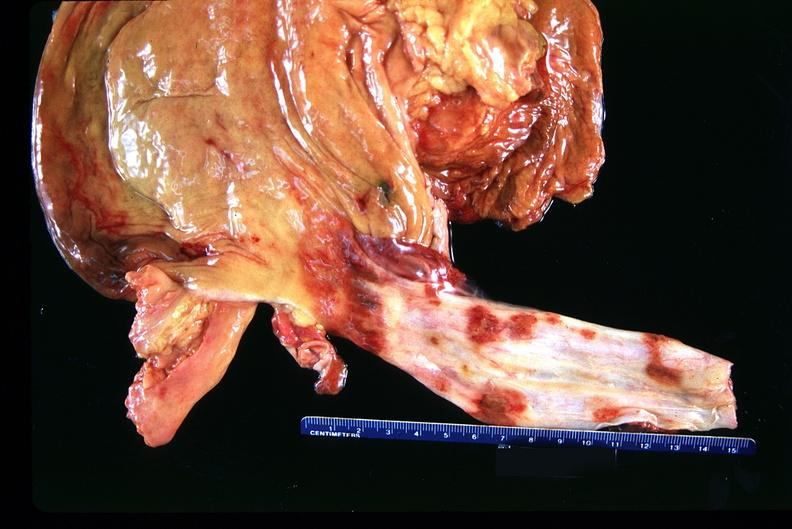where does this belong to?
Answer the question using a single word or phrase. Gastrointestinal system 